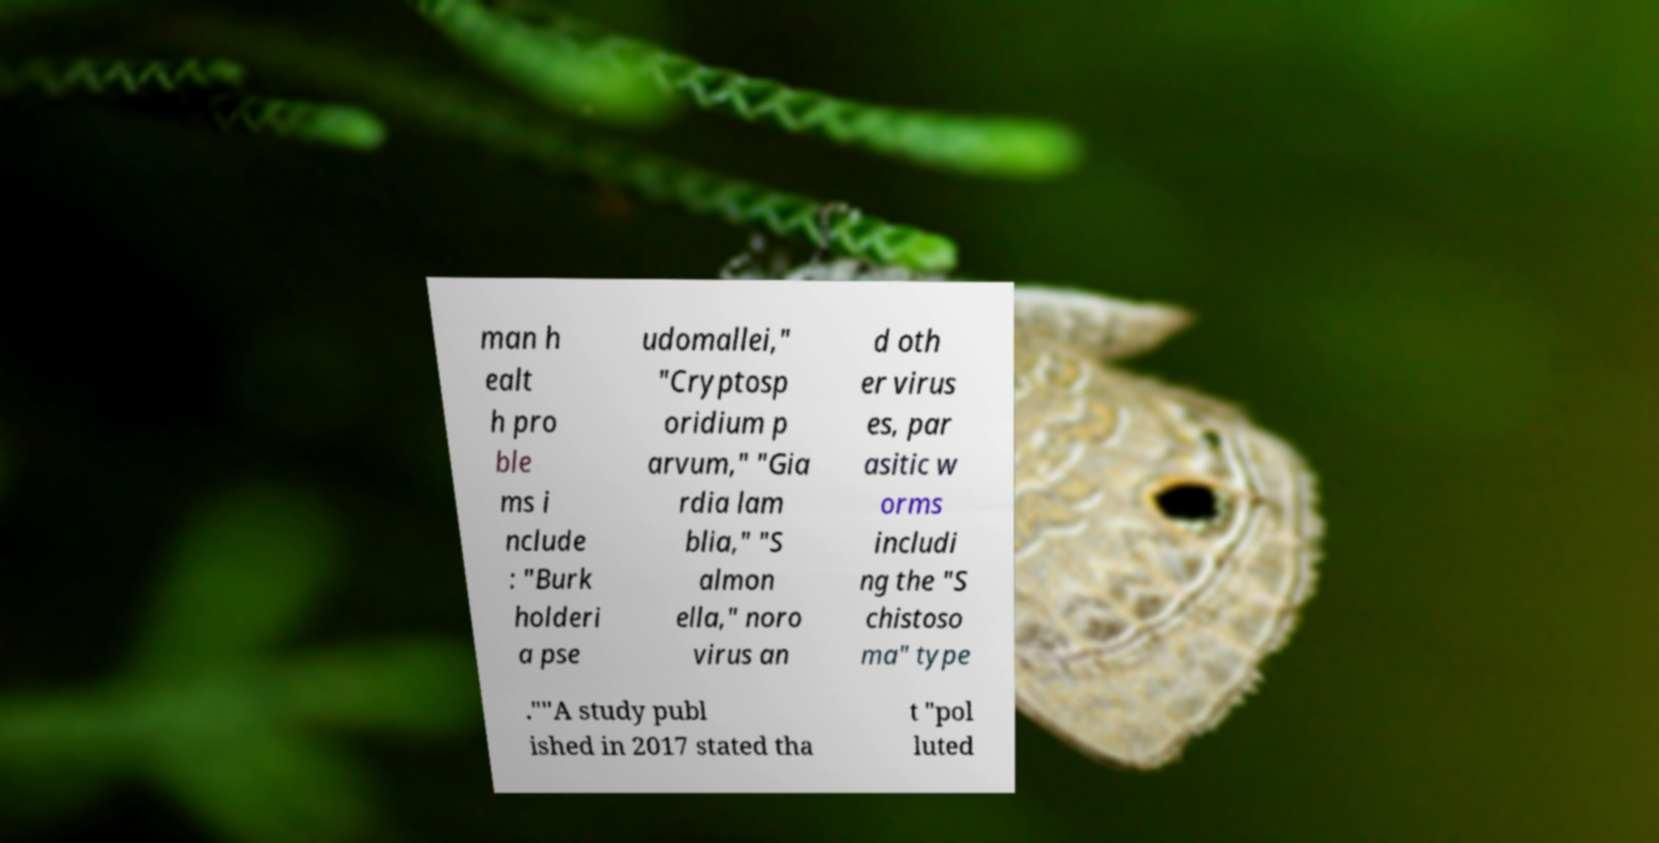Please identify and transcribe the text found in this image. man h ealt h pro ble ms i nclude : "Burk holderi a pse udomallei," "Cryptosp oridium p arvum," "Gia rdia lam blia," "S almon ella," noro virus an d oth er virus es, par asitic w orms includi ng the "S chistoso ma" type .""A study publ ished in 2017 stated tha t "pol luted 